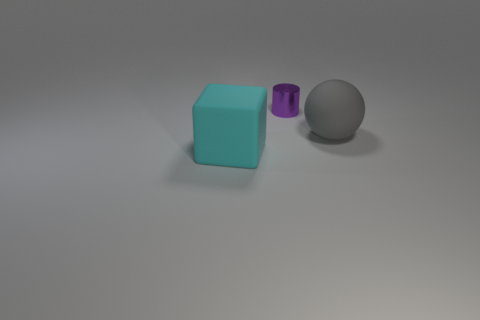What materials do the objects in the image appear to be made from? The objects in the image seem to be composed of different materials. The blue cube on the left looks like it could be made of a matte plastic, the purple cylinder in the middle has a translucent appearance which might suggest glass or acrylic, and the gray object on the right gives the impression of a metallic or rubber surface due to its muted sheen and color. 